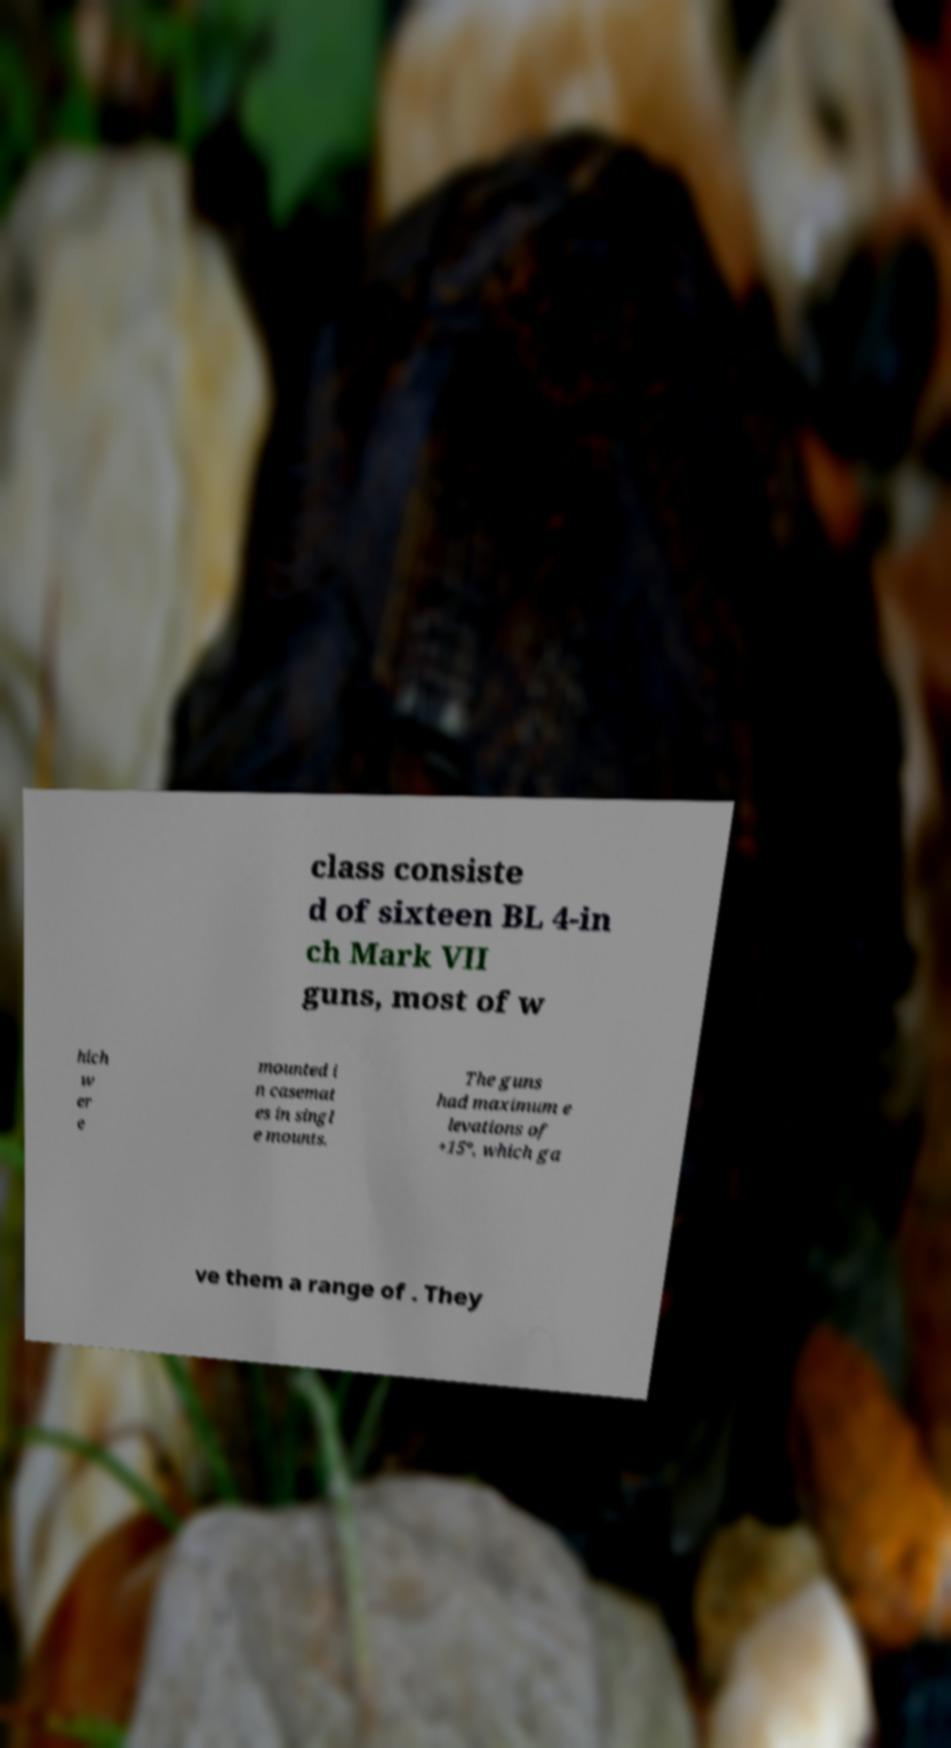Please read and relay the text visible in this image. What does it say? class consiste d of sixteen BL 4-in ch Mark VII guns, most of w hich w er e mounted i n casemat es in singl e mounts. The guns had maximum e levations of +15°, which ga ve them a range of . They 